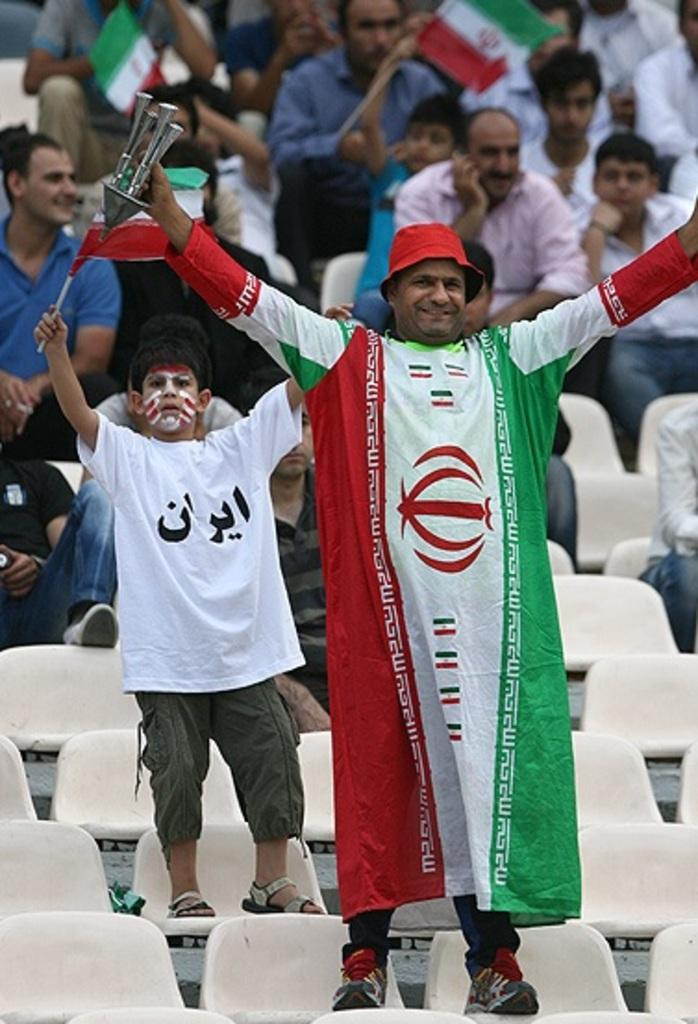How many people are in the image? There is a group of people in the image. What can be observed about the clothing of the people in the image? The people are wearing different color dresses. Can you describe the actions of one person in the image? One person is holding an object. What is another detail about the people in the image? Some people are holding flags. How many sisters are present in the image? There is no information about sisters in the image, so we cannot determine their number. 